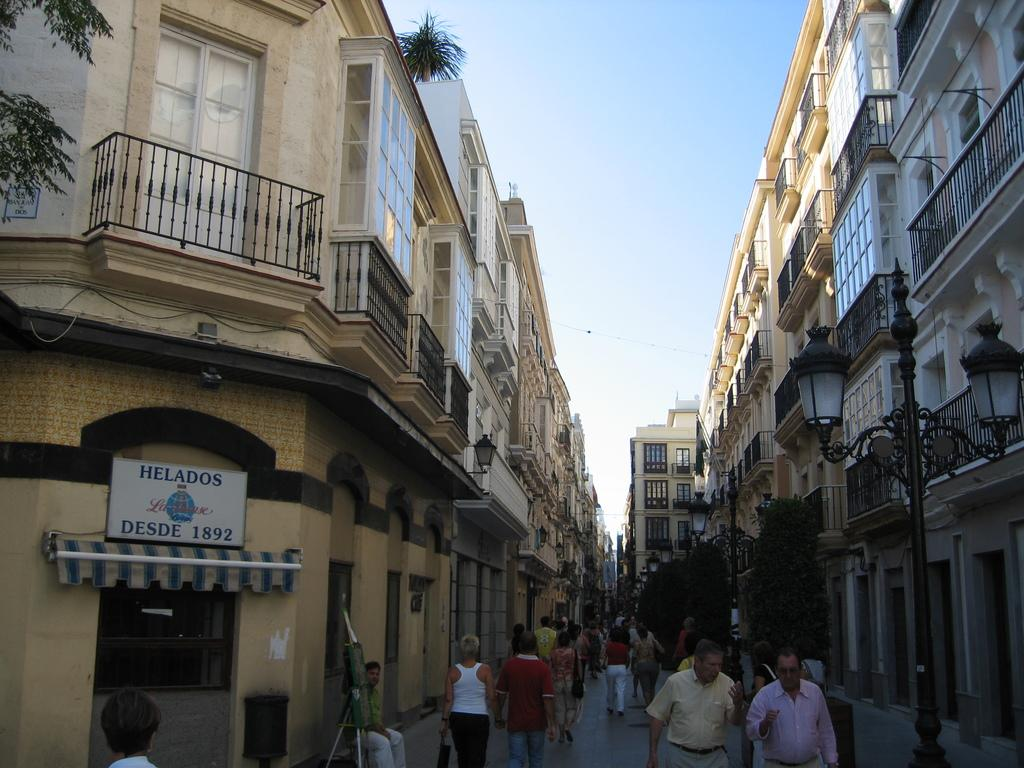What are the people in the image doing? The people in the image are walking on the road. What can be seen on both sides of the road in the image? There are buildings on both sides of the road. What is the tall structure with a light in the image? There is the light pole. What is visible at the top of the image? The sky is visible at the top of the image. What type of base is supporting the buildings in the image? There is no mention of a base supporting the buildings in the image; the buildings are standing on the ground. Is there any wax visible in the image? There is no wax present in the image. 